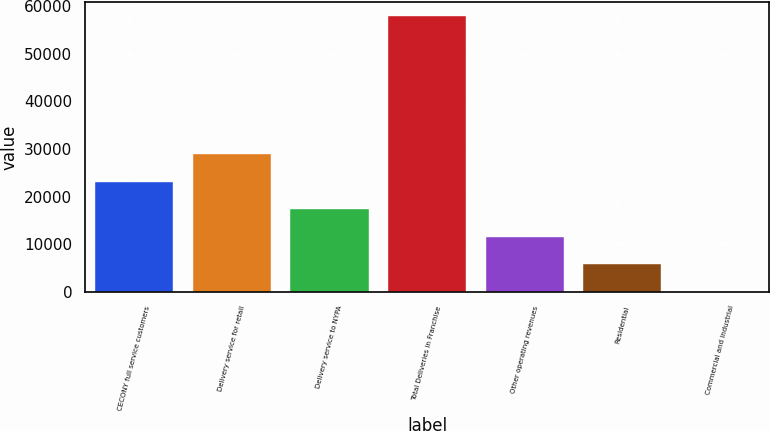<chart> <loc_0><loc_0><loc_500><loc_500><bar_chart><fcel>CECONY full service customers<fcel>Delivery service for retail<fcel>Delivery service to NYPA<fcel>Total Deliveries in Franchise<fcel>Other operating revenues<fcel>Residential<fcel>Commercial and Industrial<nl><fcel>23142.8<fcel>28923.3<fcel>17362.3<fcel>57826<fcel>11581.8<fcel>5801.23<fcel>20.7<nl></chart> 